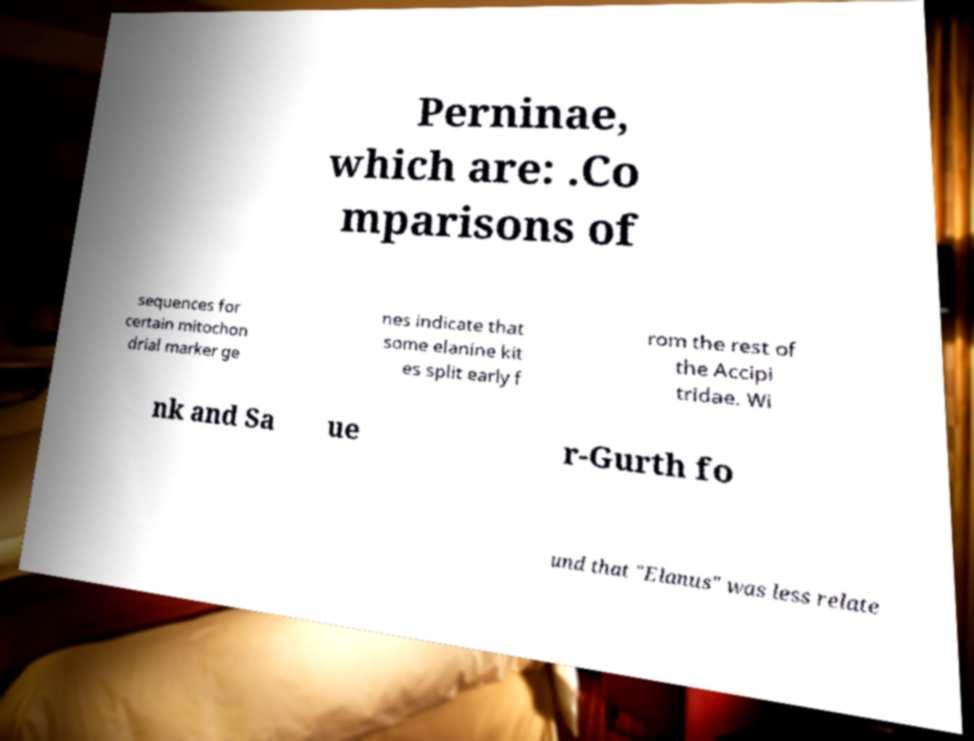What messages or text are displayed in this image? I need them in a readable, typed format. Perninae, which are: .Co mparisons of sequences for certain mitochon drial marker ge nes indicate that some elanine kit es split early f rom the rest of the Accipi tridae. Wi nk and Sa ue r-Gurth fo und that "Elanus" was less relate 